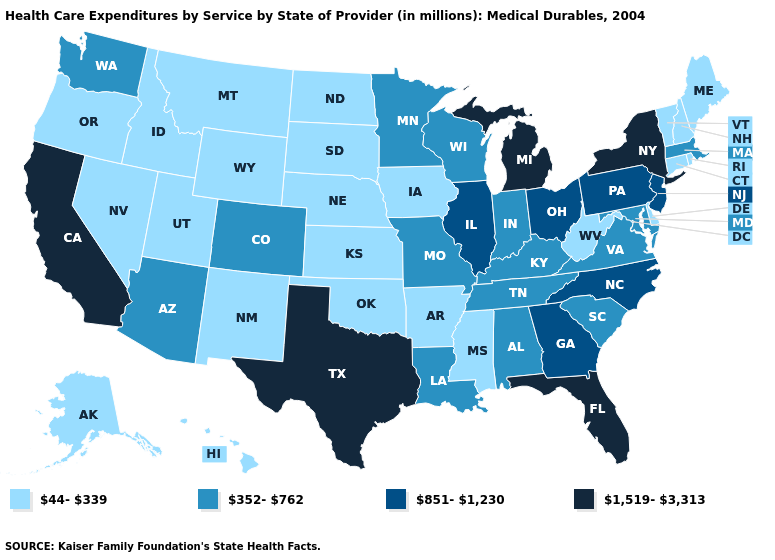Does New Hampshire have a higher value than Iowa?
Concise answer only. No. What is the value of Minnesota?
Be succinct. 352-762. Which states have the lowest value in the USA?
Be succinct. Alaska, Arkansas, Connecticut, Delaware, Hawaii, Idaho, Iowa, Kansas, Maine, Mississippi, Montana, Nebraska, Nevada, New Hampshire, New Mexico, North Dakota, Oklahoma, Oregon, Rhode Island, South Dakota, Utah, Vermont, West Virginia, Wyoming. What is the value of South Dakota?
Quick response, please. 44-339. Does Texas have the lowest value in the USA?
Answer briefly. No. Which states have the lowest value in the MidWest?
Keep it brief. Iowa, Kansas, Nebraska, North Dakota, South Dakota. Which states have the highest value in the USA?
Be succinct. California, Florida, Michigan, New York, Texas. Name the states that have a value in the range 44-339?
Give a very brief answer. Alaska, Arkansas, Connecticut, Delaware, Hawaii, Idaho, Iowa, Kansas, Maine, Mississippi, Montana, Nebraska, Nevada, New Hampshire, New Mexico, North Dakota, Oklahoma, Oregon, Rhode Island, South Dakota, Utah, Vermont, West Virginia, Wyoming. What is the value of Washington?
Quick response, please. 352-762. Name the states that have a value in the range 44-339?
Be succinct. Alaska, Arkansas, Connecticut, Delaware, Hawaii, Idaho, Iowa, Kansas, Maine, Mississippi, Montana, Nebraska, Nevada, New Hampshire, New Mexico, North Dakota, Oklahoma, Oregon, Rhode Island, South Dakota, Utah, Vermont, West Virginia, Wyoming. Does the map have missing data?
Be succinct. No. Name the states that have a value in the range 1,519-3,313?
Concise answer only. California, Florida, Michigan, New York, Texas. Does North Carolina have a higher value than New York?
Short answer required. No. What is the highest value in the USA?
Answer briefly. 1,519-3,313. Among the states that border Georgia , does Florida have the highest value?
Quick response, please. Yes. 